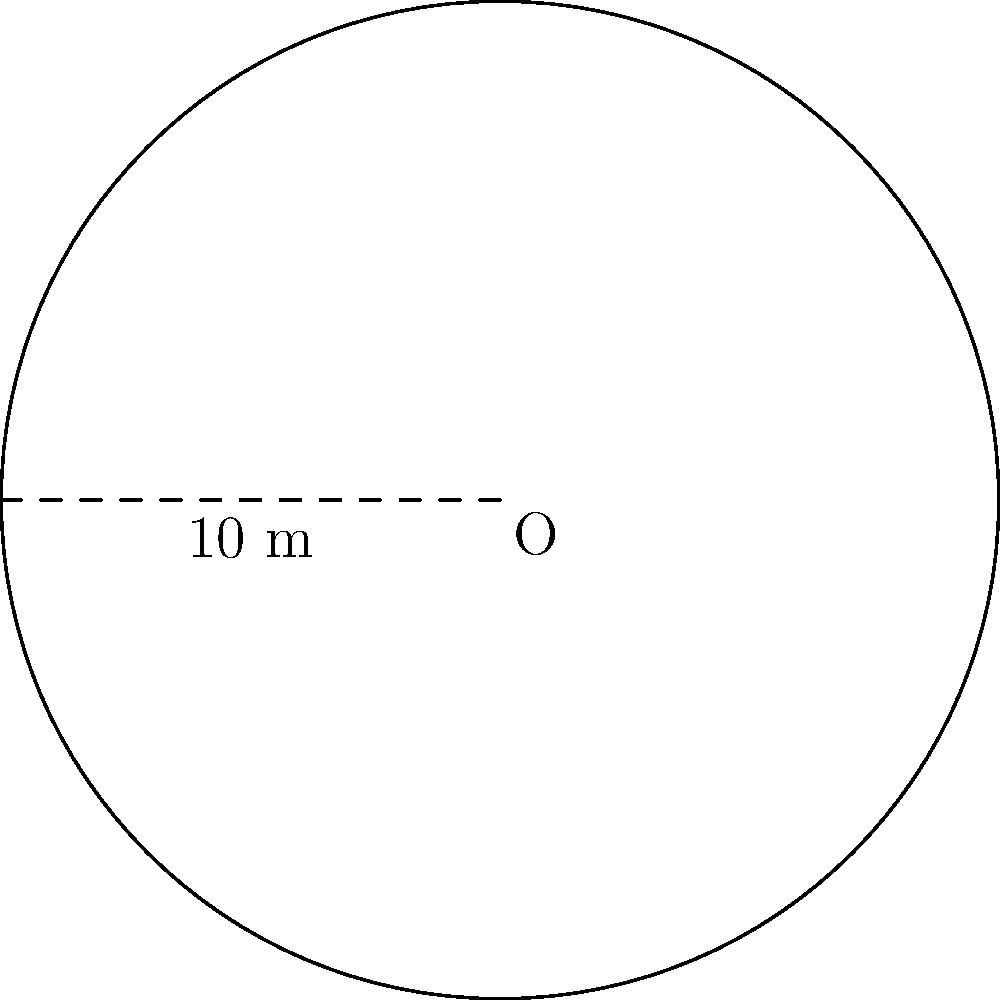You're planning a soul music concert in Wilcox County and need to calculate the area of a circular stage. If the radius of the stage is 5 meters, what is the total area of the stage in square meters? Round your answer to the nearest whole number. To find the area of a circular stage, we need to use the formula for the area of a circle:

$$A = \pi r^2$$

Where:
$A$ = area of the circle
$\pi$ (pi) ≈ 3.14159
$r$ = radius of the circle

Given:
Radius ($r$) = 5 meters

Let's calculate:

1) Substitute the values into the formula:
   $$A = \pi \times 5^2$$

2) Calculate the square of the radius:
   $$A = \pi \times 25$$

3) Multiply by pi:
   $$A = 3.14159 \times 25 = 78.53975$$

4) Round to the nearest whole number:
   $$A \approx 79$$

Therefore, the area of the circular stage is approximately 79 square meters.
Answer: 79 sq m 